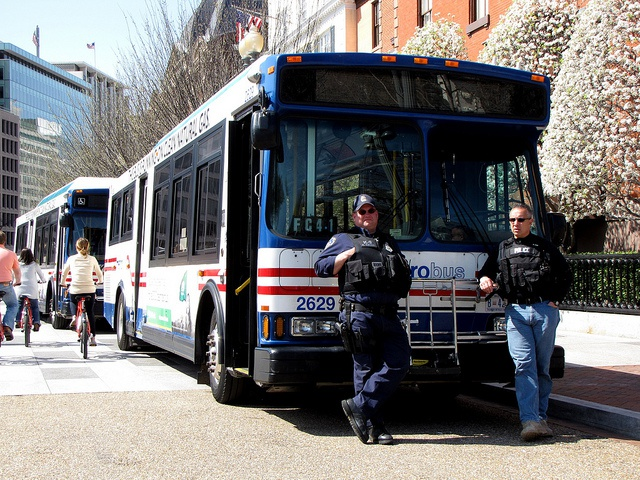Describe the objects in this image and their specific colors. I can see bus in lightblue, black, white, gray, and navy tones, people in lightblue, black, gray, and navy tones, people in lightblue, black, navy, gray, and darkblue tones, bus in lightblue, black, white, gray, and navy tones, and people in white, black, and tan tones in this image. 